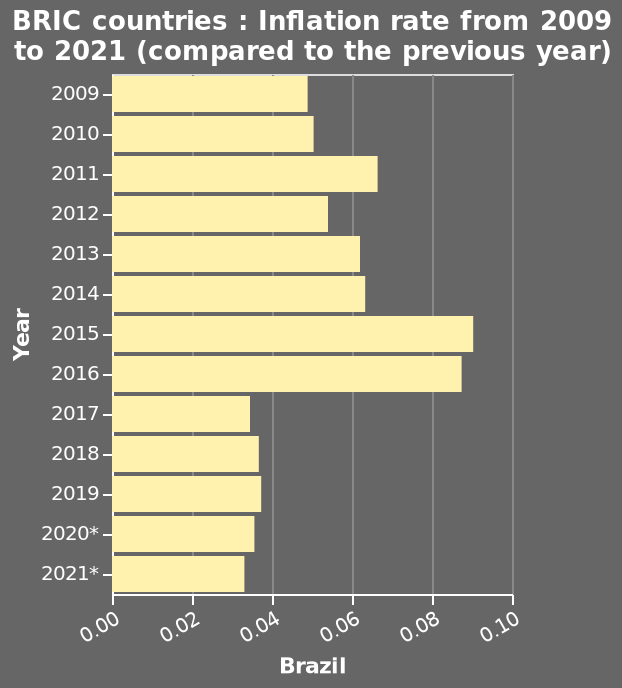<image>
What is the time period covered by the bar diagram? The bar diagram covers the years from 2009 to 2021. Which year had the highest inflation rate in Brazil? The highest inflation rate in Brazil was registered in 2015. Did the inflation rate in Brazil decrease after 2017? Yes, the inflation rate in Brazil dropped below 0.04 after 2017. 